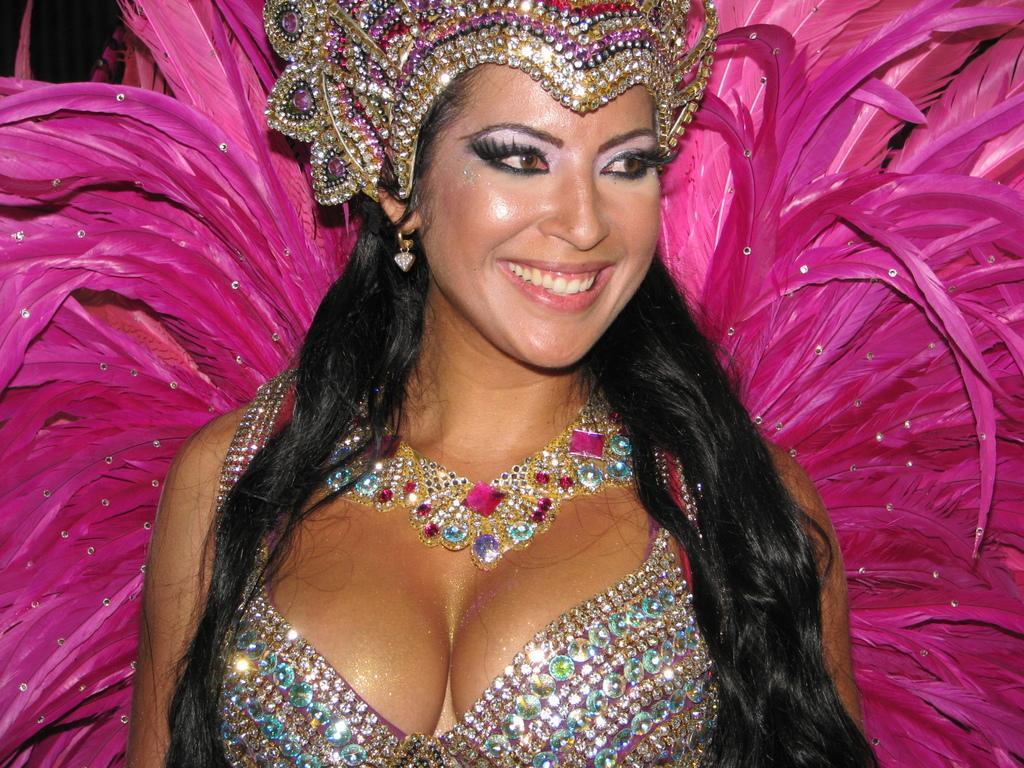How would you summarize this image in a sentence or two? In this image I can see a woman is wearing a costume and smiling by looking at the right side. 